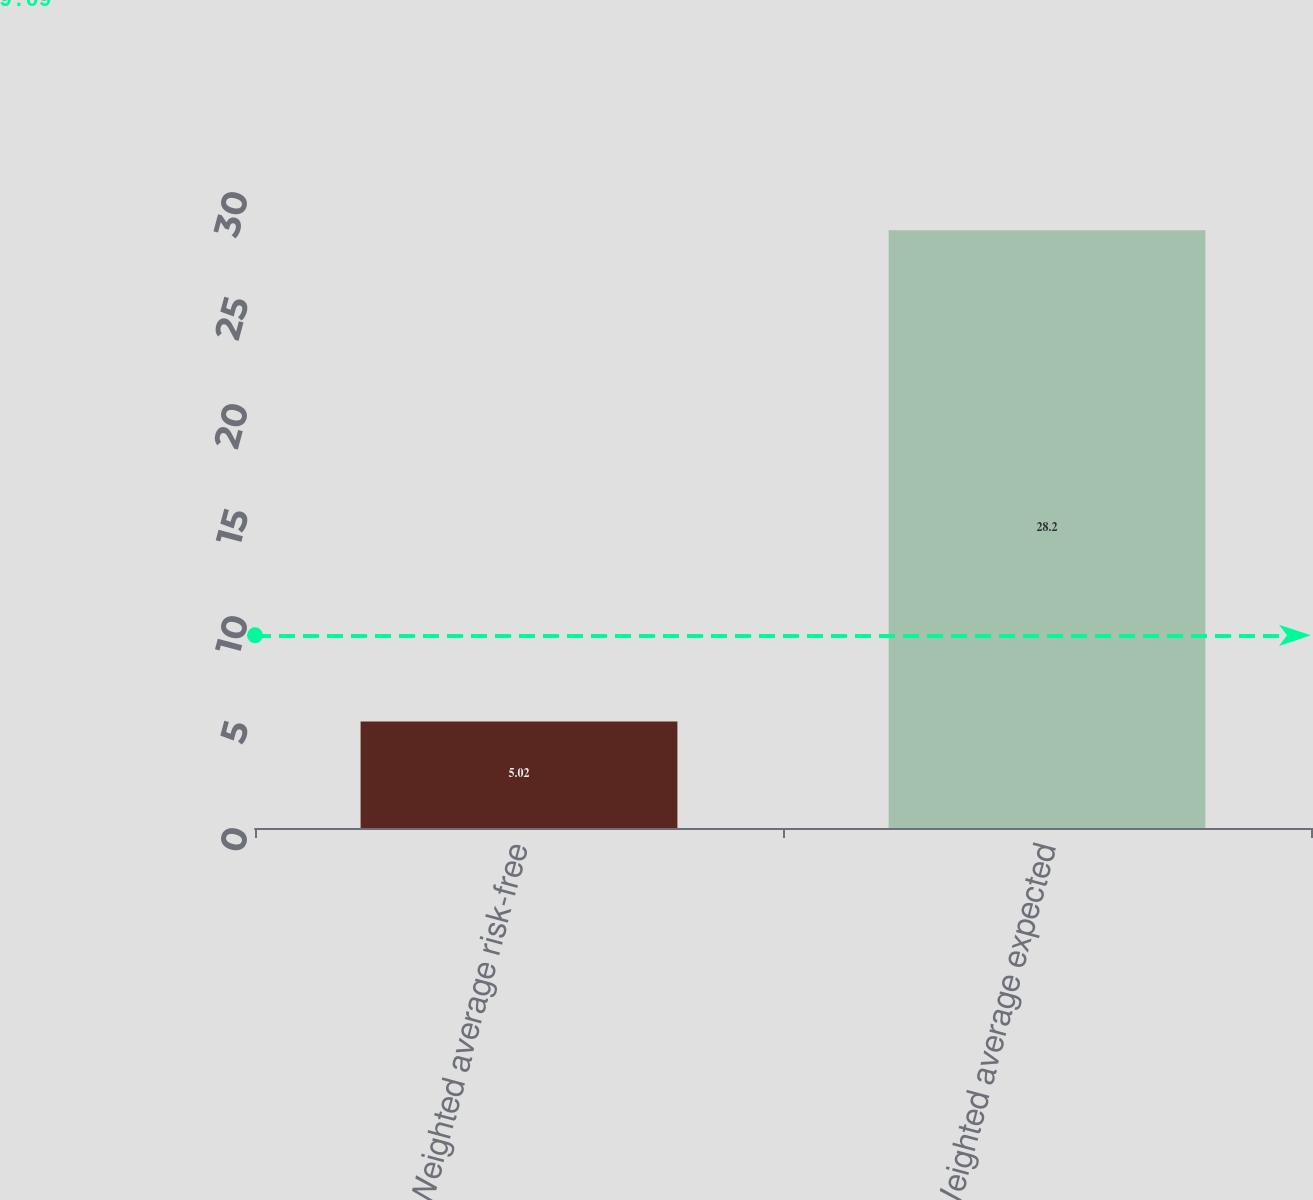<chart> <loc_0><loc_0><loc_500><loc_500><bar_chart><fcel>Weighted average risk-free<fcel>Weighted average expected<nl><fcel>5.02<fcel>28.2<nl></chart> 